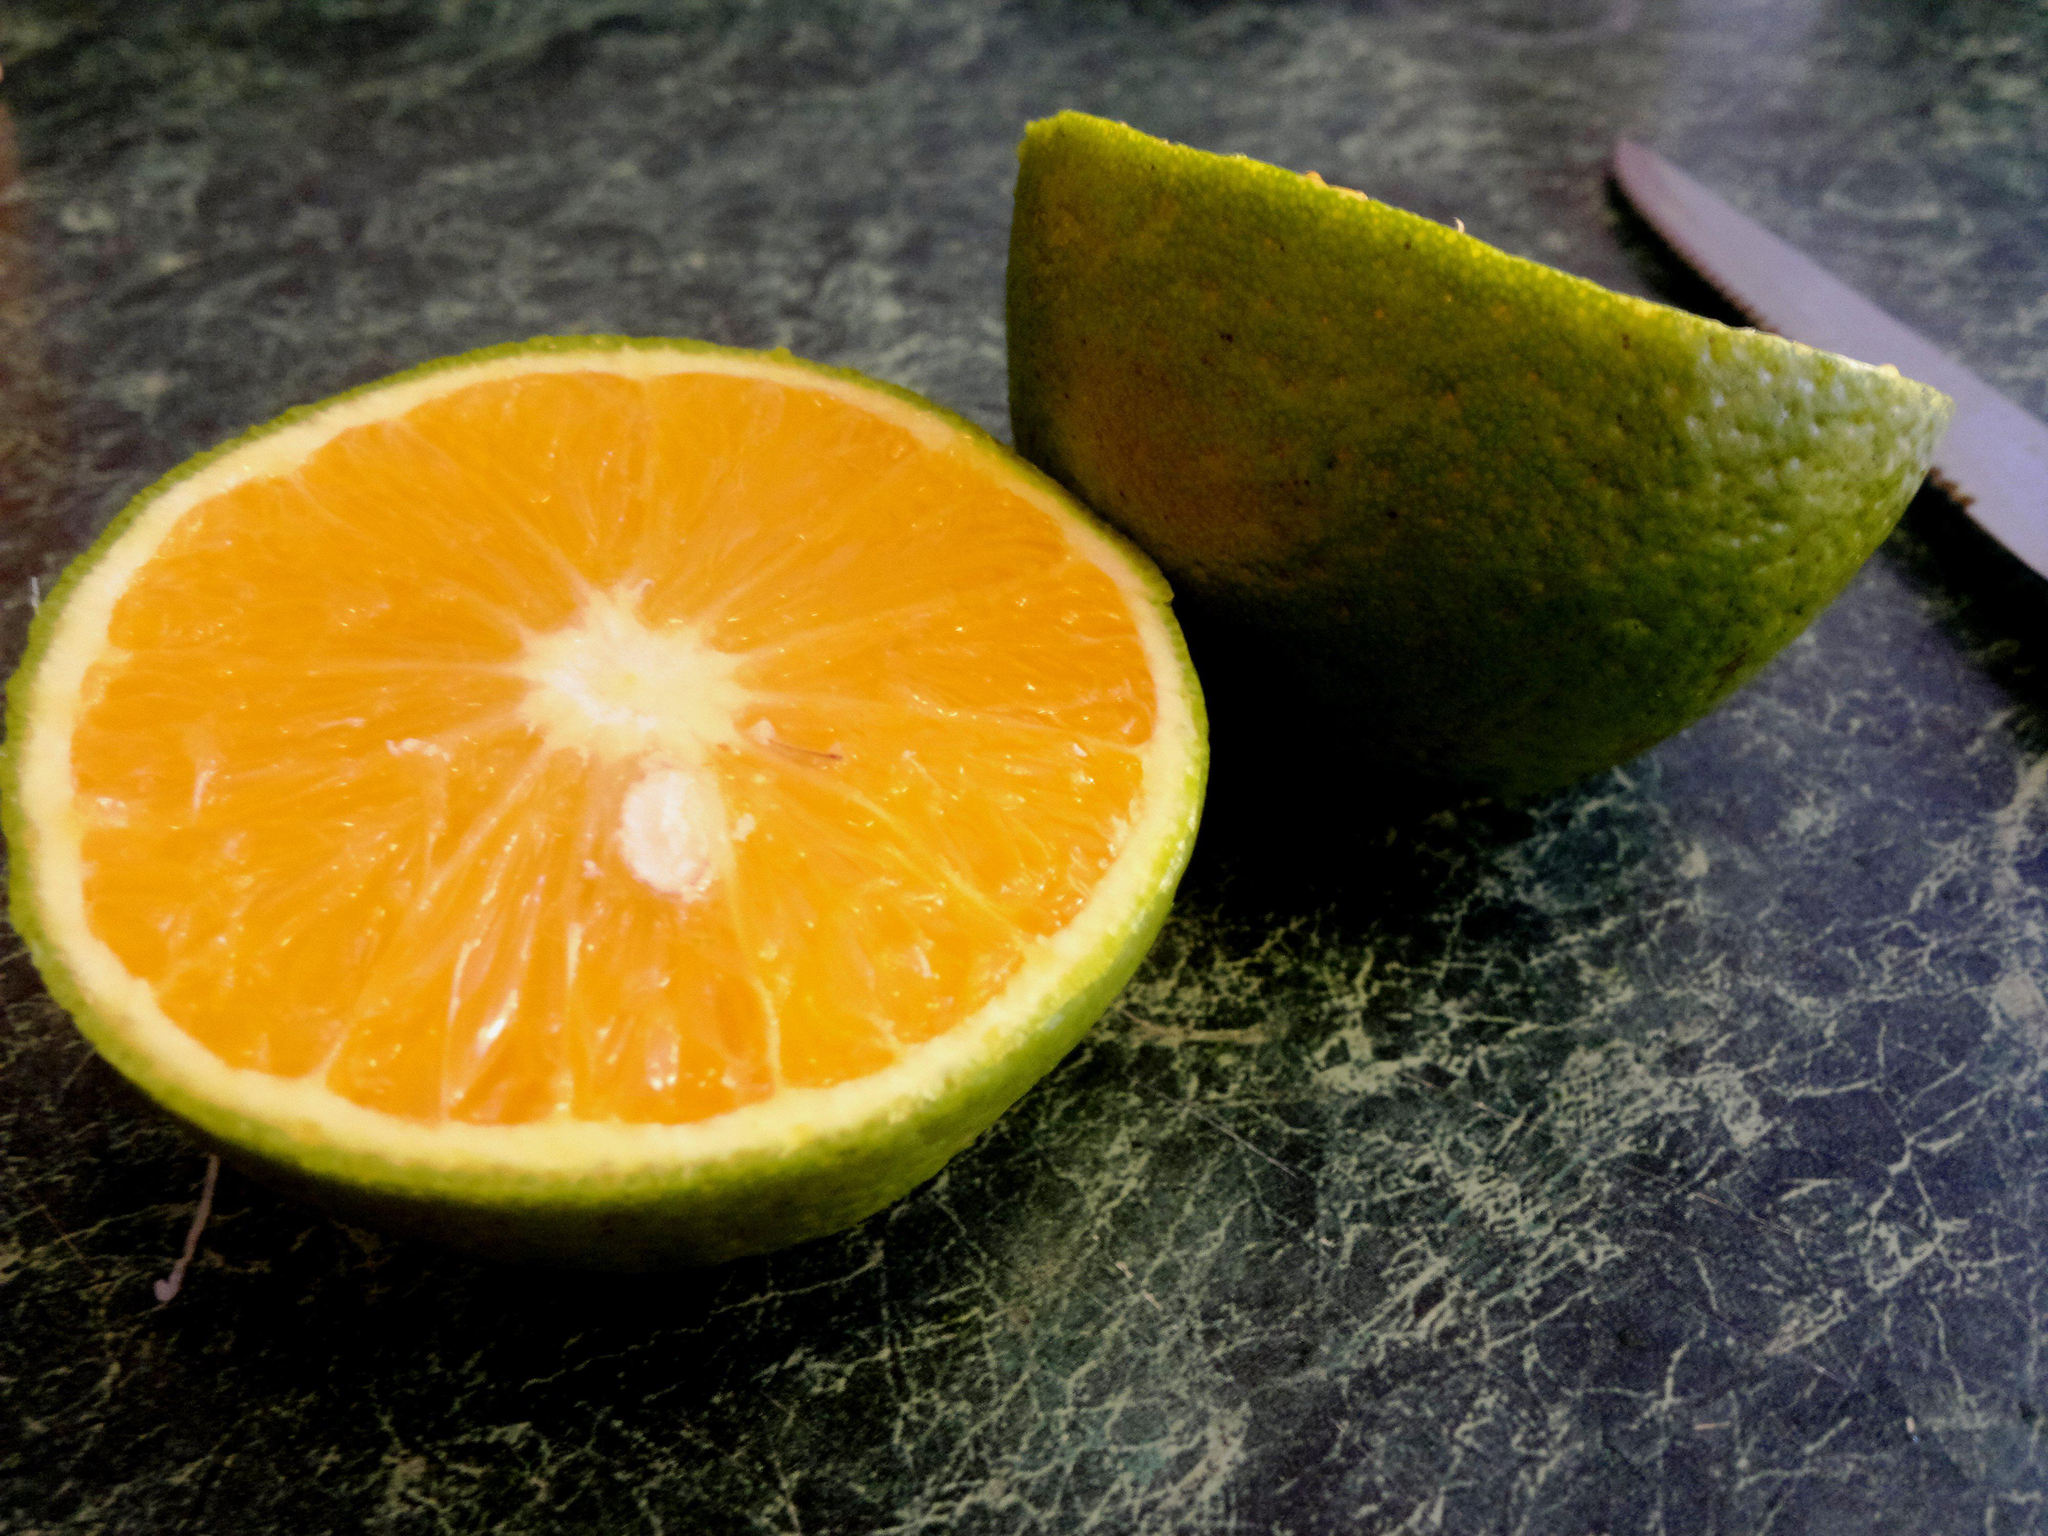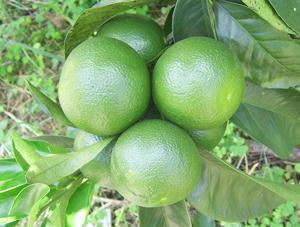The first image is the image on the left, the second image is the image on the right. For the images shown, is this caption "There are at least 3 half mandarin fruit slices." true? Answer yes or no. No. The first image is the image on the left, the second image is the image on the right. For the images shown, is this caption "The fruit in only ONE of the images was cut with a knife." true? Answer yes or no. Yes. 